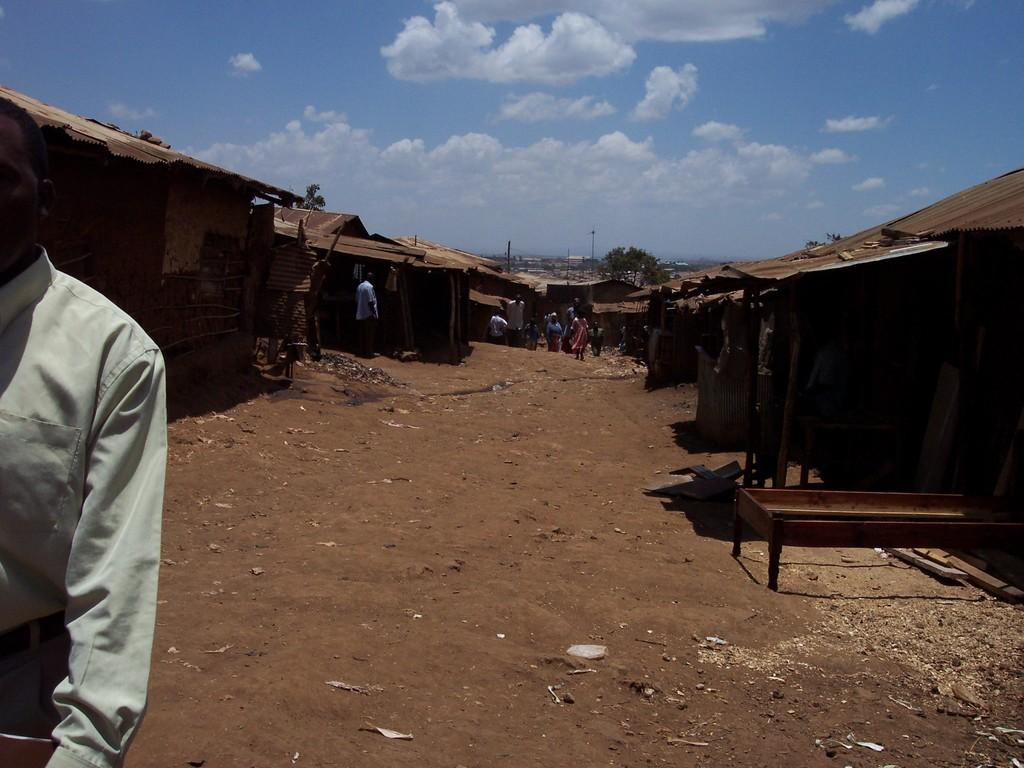What type of structures can be seen in the image? There are small houses and huts in the image. How many people are present in the image? There are many people in the image. What is located at the bottom of the image? There is a road at the bottom of the image. How many feet are visible in the image? There is no specific mention of feet in the image, so it is not possible to determine how many are visible. 